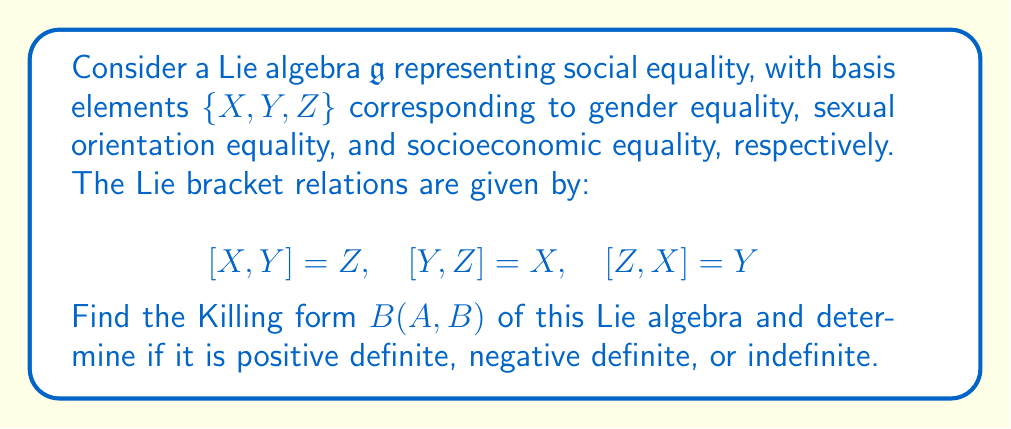Give your solution to this math problem. To find the Killing form of the Lie algebra $\mathfrak{g}$, we need to follow these steps:

1) The Killing form is defined as $B(A, B) = \text{tr}(\text{ad}(A) \circ \text{ad}(B))$, where $\text{ad}(A)$ is the adjoint representation of $A$.

2) First, we need to find the matrix representations of $\text{ad}(X)$, $\text{ad}(Y)$, and $\text{ad}(Z)$:

   $\text{ad}(X) = \begin{pmatrix} 0 & 0 & -1 \\ 0 & 0 & 0 \\ 0 & 1 & 0 \end{pmatrix}$

   $\text{ad}(Y) = \begin{pmatrix} 0 & 0 & 0 \\ 0 & 0 & -1 \\ 1 & 0 & 0 \end{pmatrix}$

   $\text{ad}(Z) = \begin{pmatrix} 0 & -1 & 0 \\ 1 & 0 & 0 \\ 0 & 0 & 0 \end{pmatrix}$

3) Now, we calculate $B(X,X)$, $B(Y,Y)$, and $B(Z,Z)$:

   $B(X,X) = \text{tr}(\text{ad}(X) \circ \text{ad}(X)) = \text{tr}\begin{pmatrix} -1 & 0 & 0 \\ 0 & -1 & 0 \\ 0 & 0 & -1 \end{pmatrix} = -3$

   Similarly, $B(Y,Y) = B(Z,Z) = -3$

4) For the off-diagonal elements:

   $B(X,Y) = B(Y,X) = \text{tr}(\text{ad}(X) \circ \text{ad}(Y)) = \text{tr}\begin{pmatrix} 0 & 1 & 0 \\ -1 & 0 & 0 \\ 0 & 0 & 0 \end{pmatrix} = 0$

   Similarly, $B(X,Z) = B(Z,X) = B(Y,Z) = B(Z,Y) = 0$

5) Therefore, the Killing form matrix is:

   $B = \begin{pmatrix} -3 & 0 & 0 \\ 0 & -3 & 0 \\ 0 & 0 & -3 \end{pmatrix}$

6) The Killing form is negative definite because all its eigenvalues are negative.
Answer: The Killing form of the given Lie algebra is $B = \text{diag}(-3, -3, -3)$, which is negative definite. 